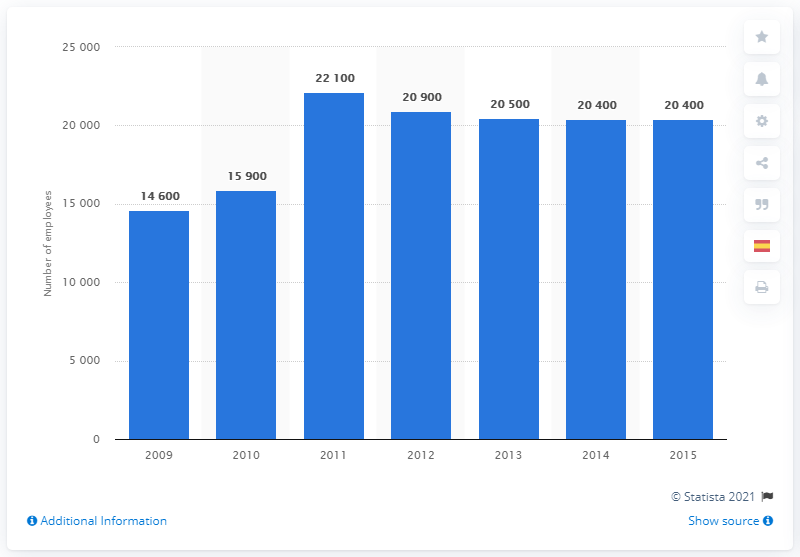List a handful of essential elements in this visual. As of 2009, Terex's most recent fiscal year was. 